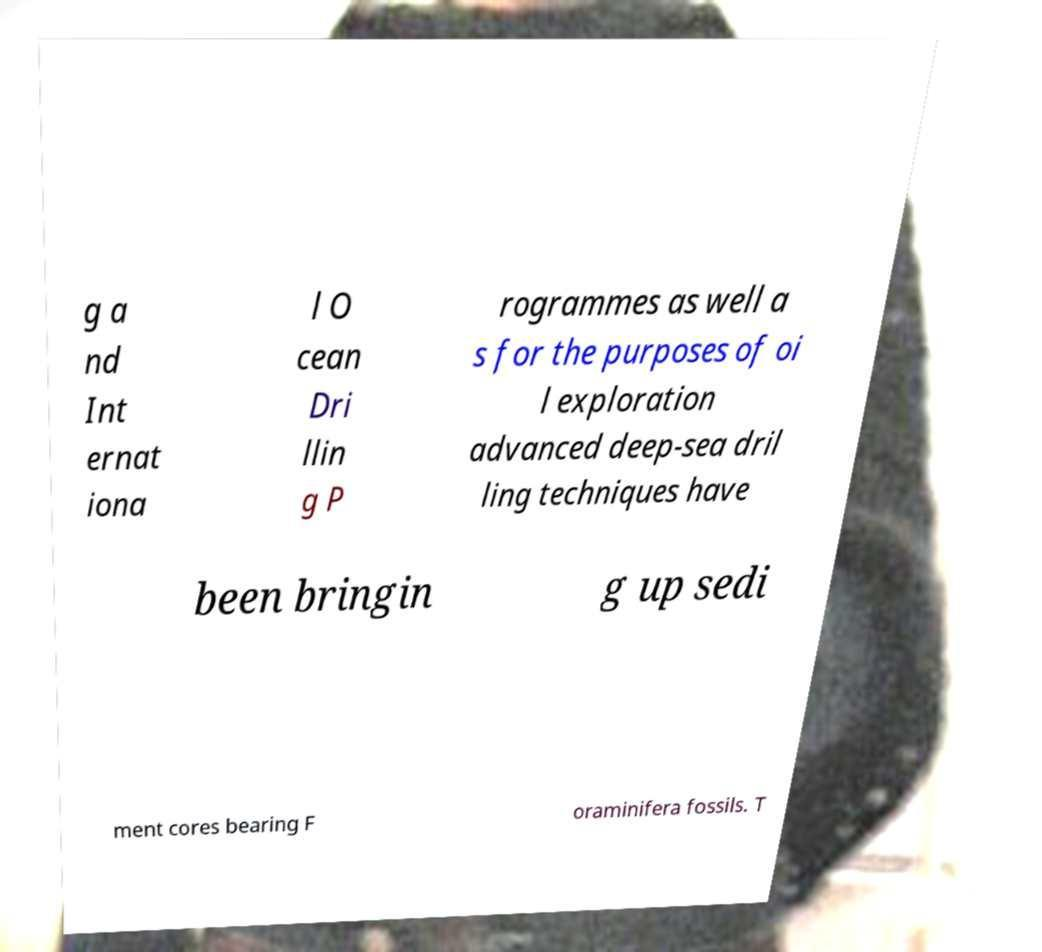Can you accurately transcribe the text from the provided image for me? g a nd Int ernat iona l O cean Dri llin g P rogrammes as well a s for the purposes of oi l exploration advanced deep-sea dril ling techniques have been bringin g up sedi ment cores bearing F oraminifera fossils. T 